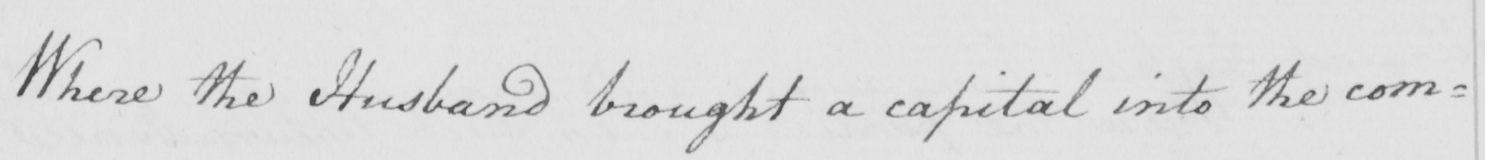Transcribe the text shown in this historical manuscript line. Where the husband brought a capital into the com= 